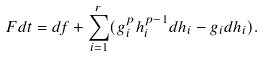<formula> <loc_0><loc_0><loc_500><loc_500>F d t = d f + \sum _ { i = 1 } ^ { r } ( g _ { i } ^ { p } h _ { i } ^ { p - 1 } d h _ { i } - g _ { i } d h _ { i } ) .</formula> 